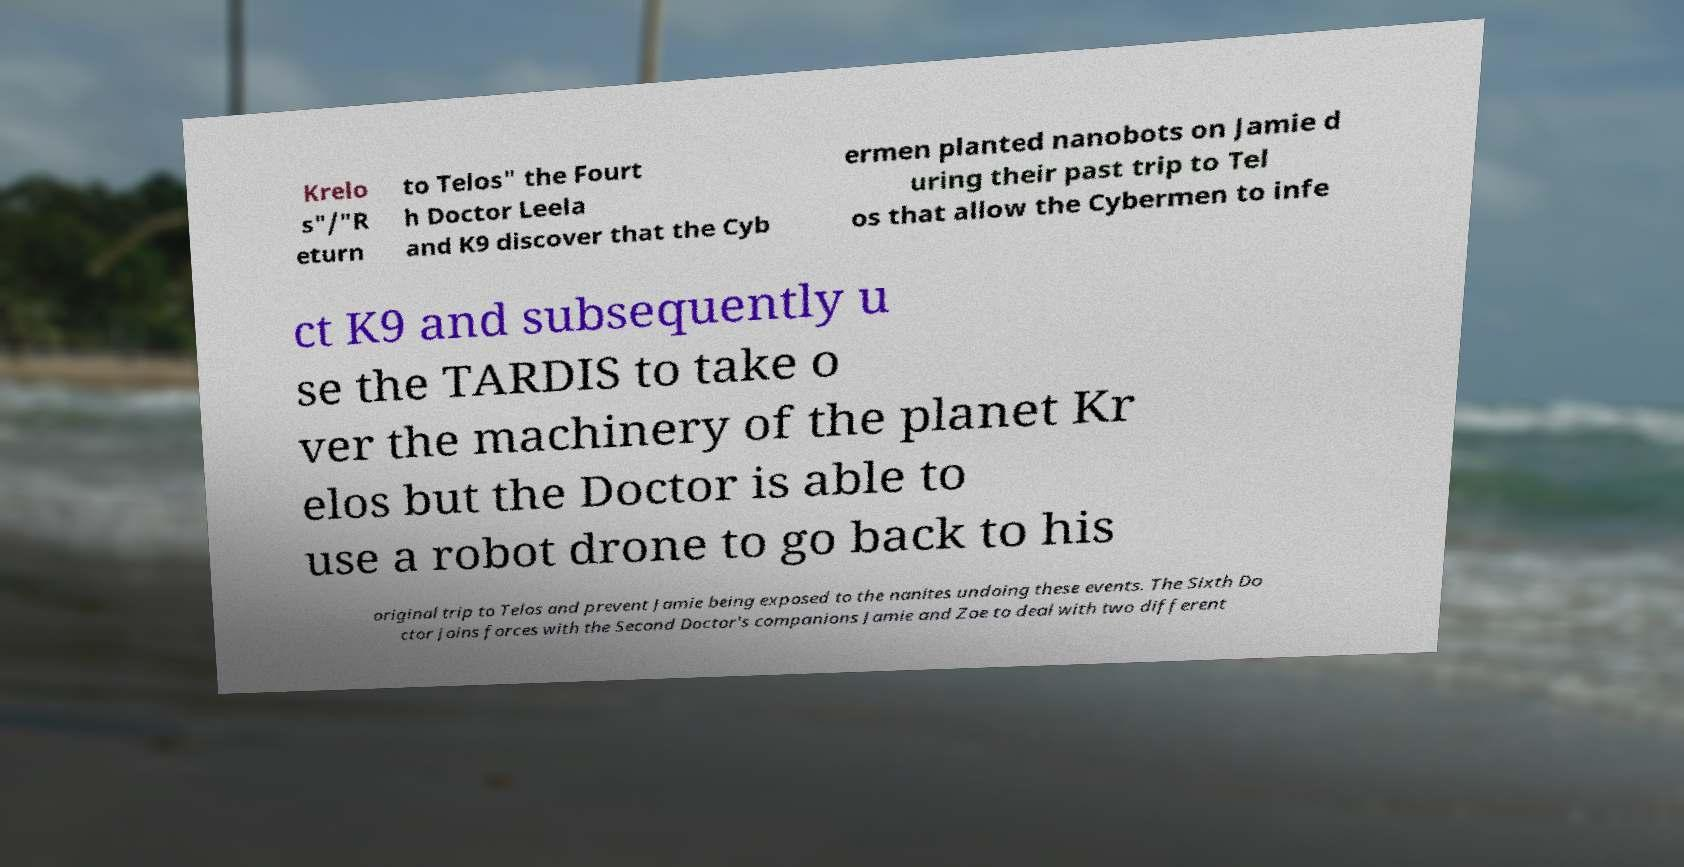Can you read and provide the text displayed in the image?This photo seems to have some interesting text. Can you extract and type it out for me? Krelo s"/"R eturn to Telos" the Fourt h Doctor Leela and K9 discover that the Cyb ermen planted nanobots on Jamie d uring their past trip to Tel os that allow the Cybermen to infe ct K9 and subsequently u se the TARDIS to take o ver the machinery of the planet Kr elos but the Doctor is able to use a robot drone to go back to his original trip to Telos and prevent Jamie being exposed to the nanites undoing these events. The Sixth Do ctor joins forces with the Second Doctor's companions Jamie and Zoe to deal with two different 